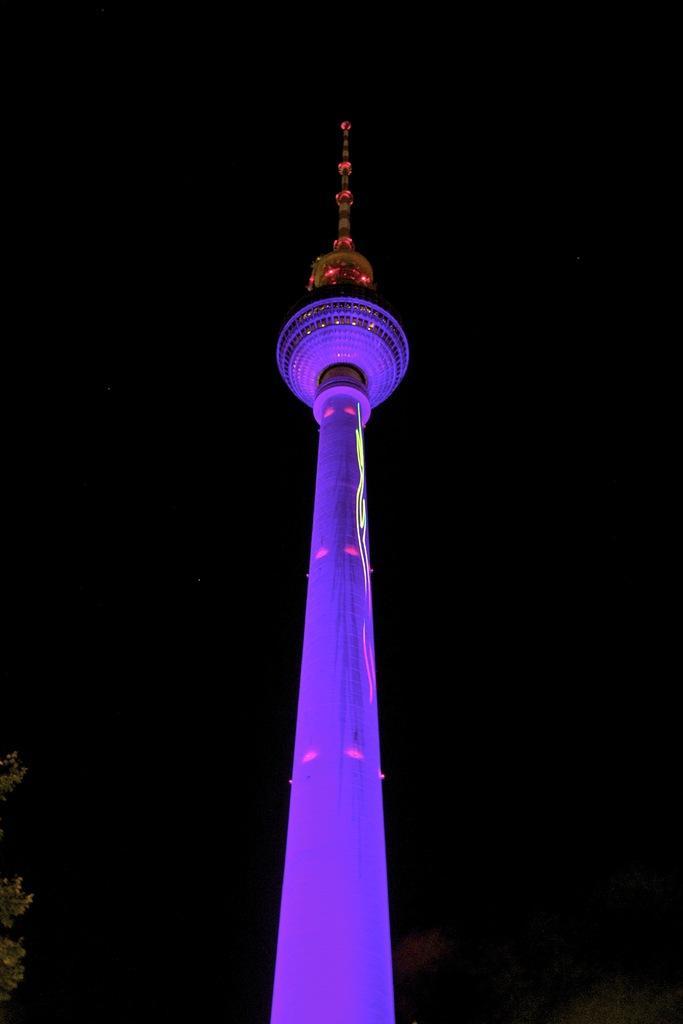Can you describe this image briefly? In this picture we can see a tower, there is a dark background, we can see a tree at the left bottom. 